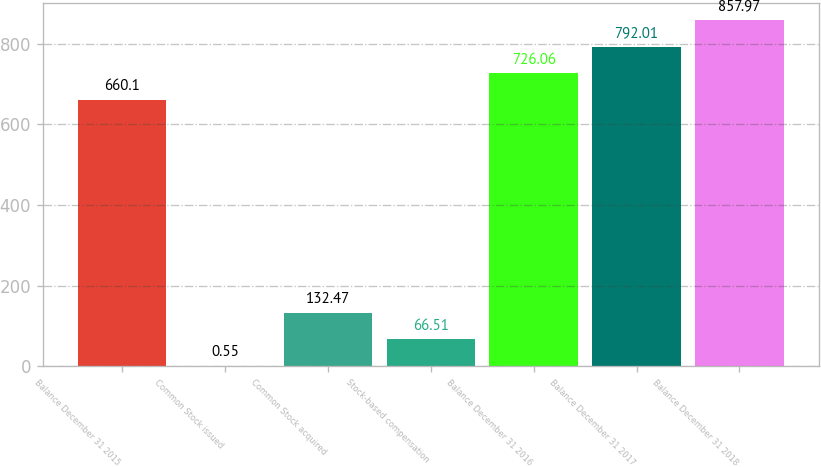<chart> <loc_0><loc_0><loc_500><loc_500><bar_chart><fcel>Balance December 31 2015<fcel>Common Stock issued<fcel>Common Stock acquired<fcel>Stock-based compensation<fcel>Balance December 31 2016<fcel>Balance December 31 2017<fcel>Balance December 31 2018<nl><fcel>660.1<fcel>0.55<fcel>132.47<fcel>66.51<fcel>726.06<fcel>792.01<fcel>857.97<nl></chart> 